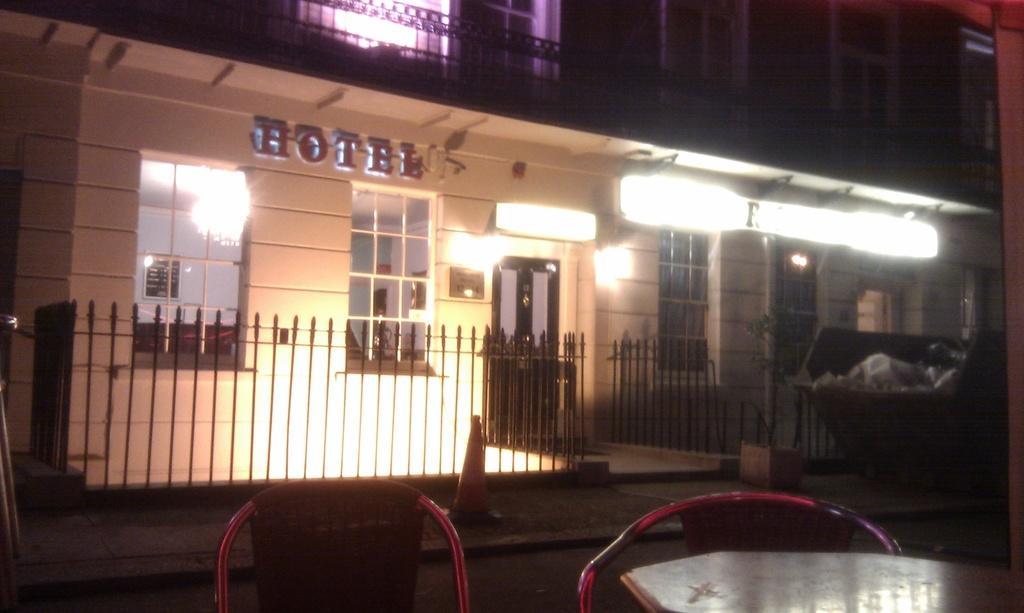How would you summarize this image in a sentence or two? In this image, we can see a building. There is a fencing in the middle of the image. There are chairs at the bottom of the image. There is a trash bin on the right side of the image. There are lights on the building. 